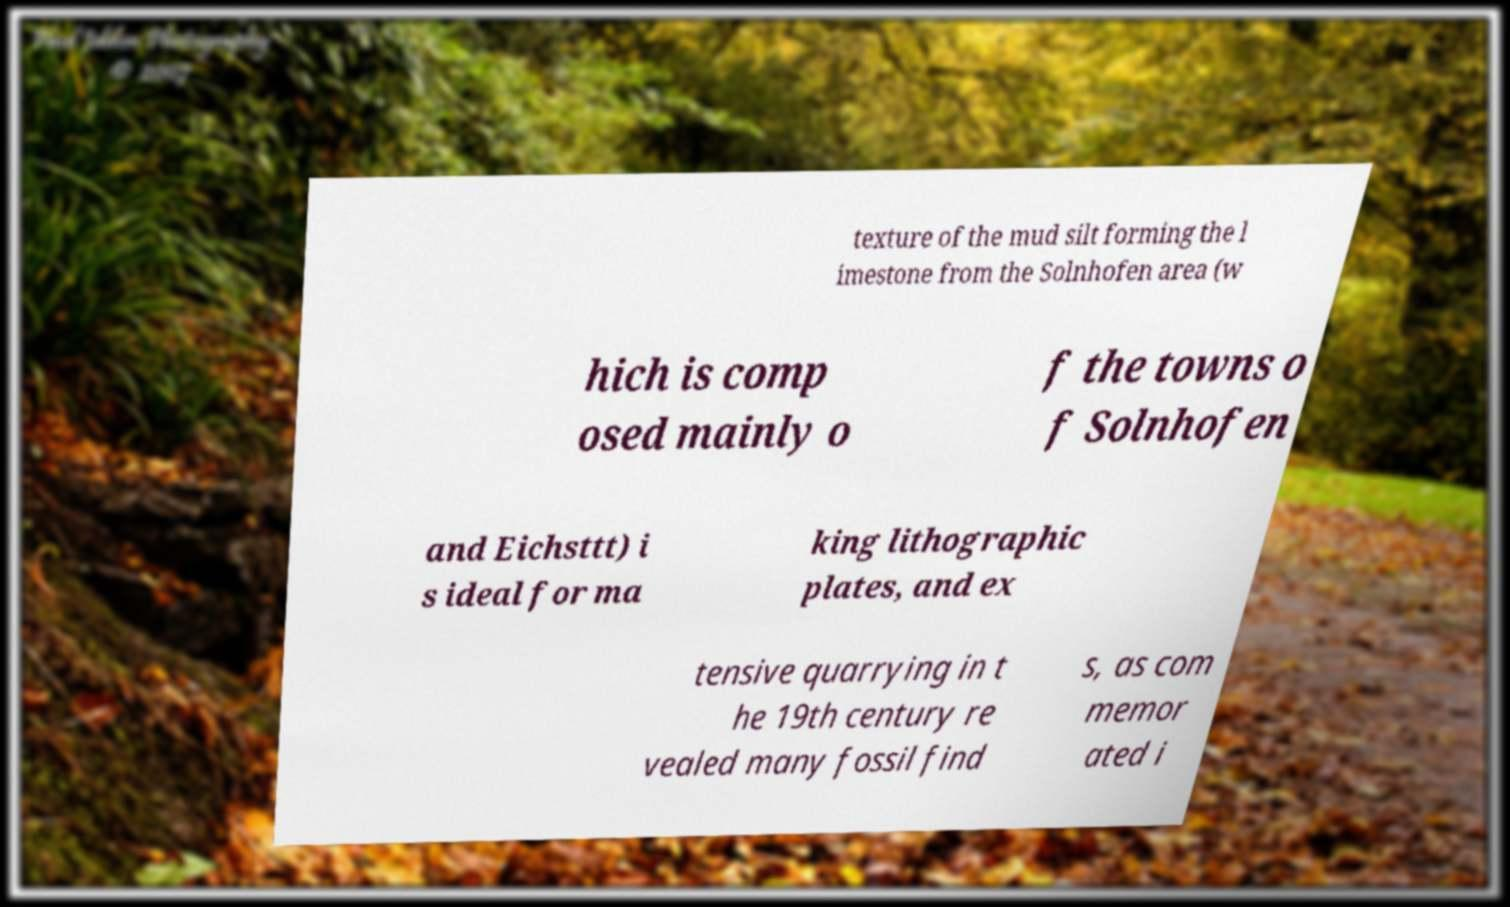For documentation purposes, I need the text within this image transcribed. Could you provide that? texture of the mud silt forming the l imestone from the Solnhofen area (w hich is comp osed mainly o f the towns o f Solnhofen and Eichsttt) i s ideal for ma king lithographic plates, and ex tensive quarrying in t he 19th century re vealed many fossil find s, as com memor ated i 